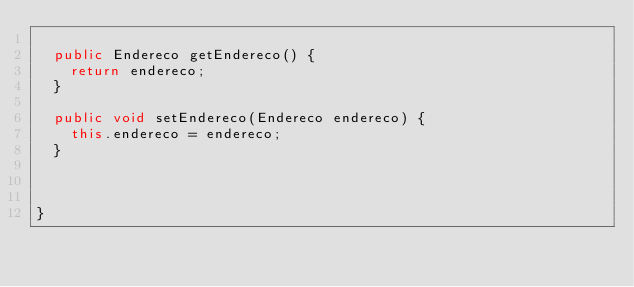Convert code to text. <code><loc_0><loc_0><loc_500><loc_500><_Java_>
	public Endereco getEndereco() {
		return endereco;
	}

	public void setEndereco(Endereco endereco) {
		this.endereco = endereco;
	}
	
	
	
}
</code> 